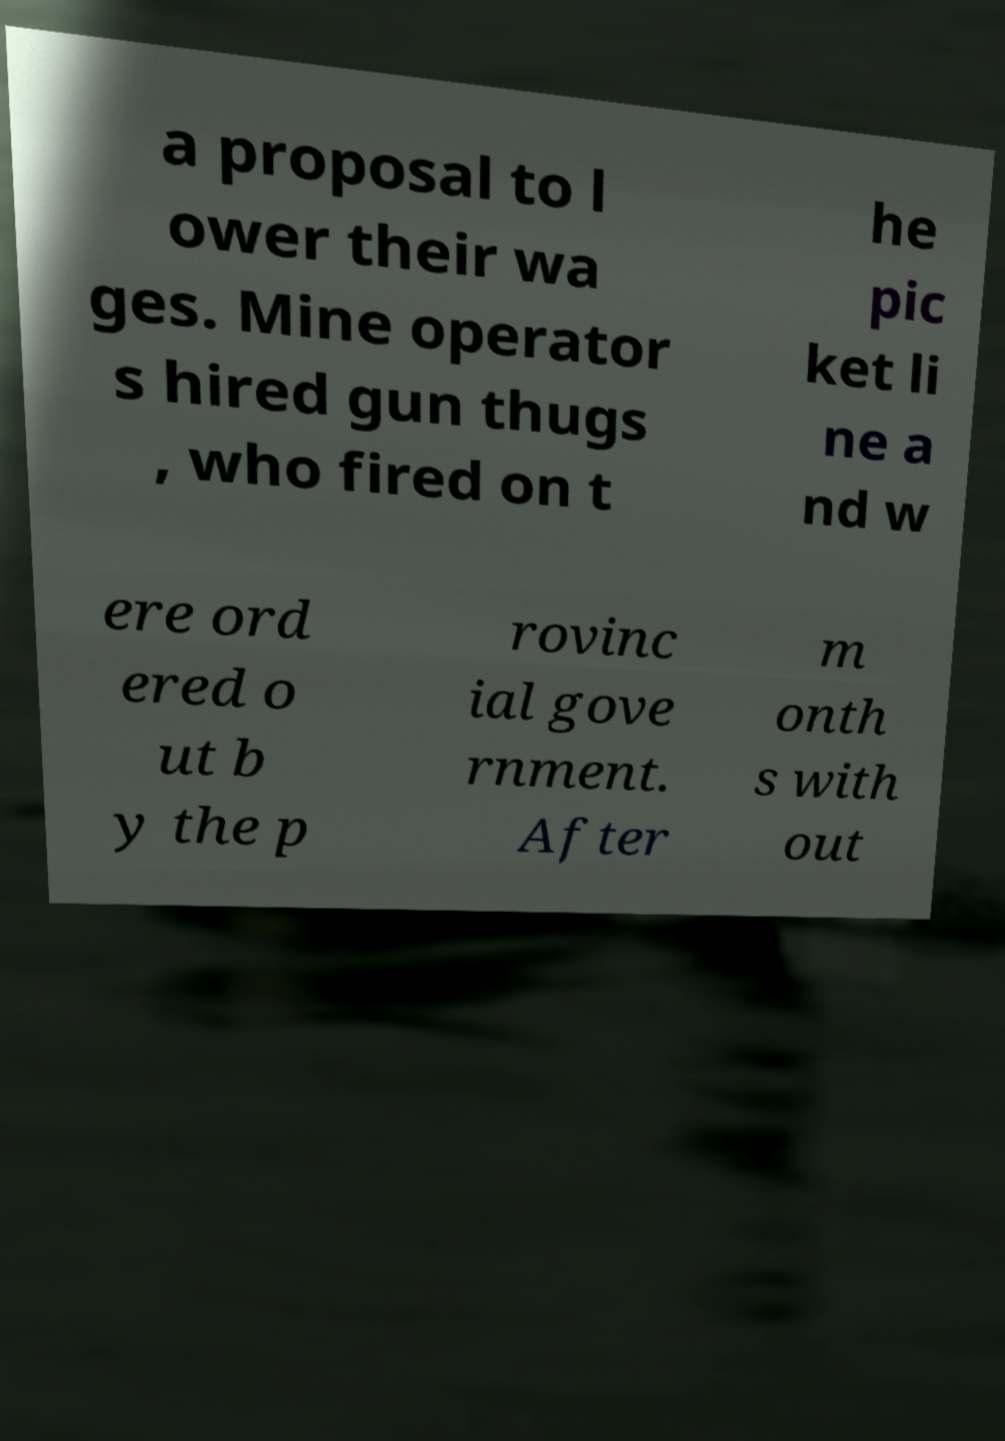Please identify and transcribe the text found in this image. a proposal to l ower their wa ges. Mine operator s hired gun thugs , who fired on t he pic ket li ne a nd w ere ord ered o ut b y the p rovinc ial gove rnment. After m onth s with out 